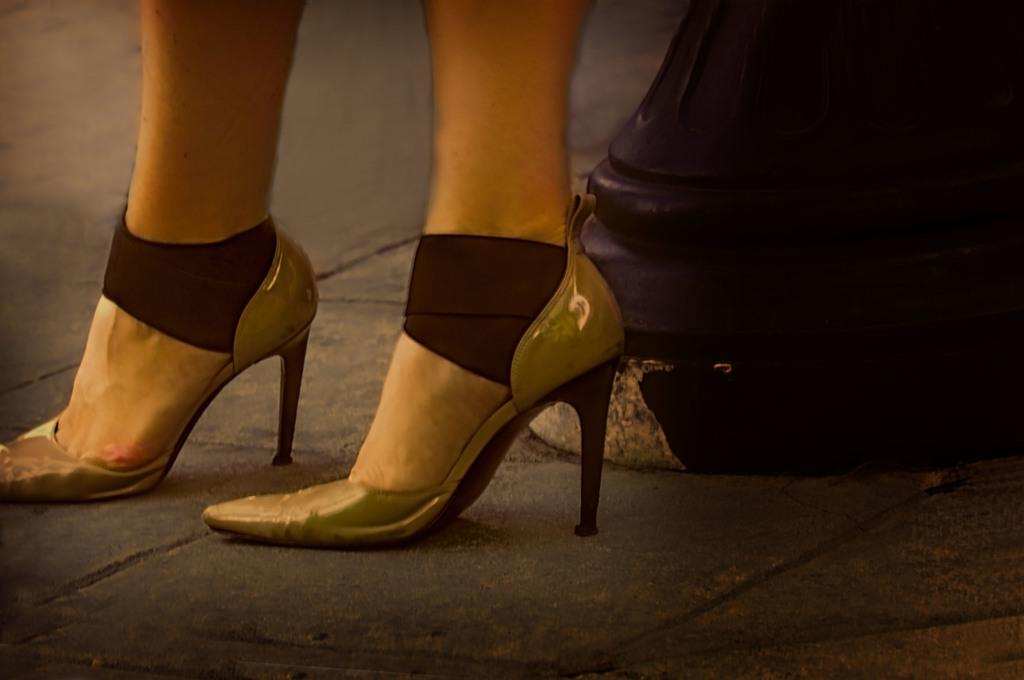What part of a person's body is visible in the image? There is a person's legs in the image. What type of clothing is the person wearing on their feet? The person is wearing footwear in the image. Can you see a river flowing in the background of the image? There is no river visible in the image; only a person's legs and footwear are present. 